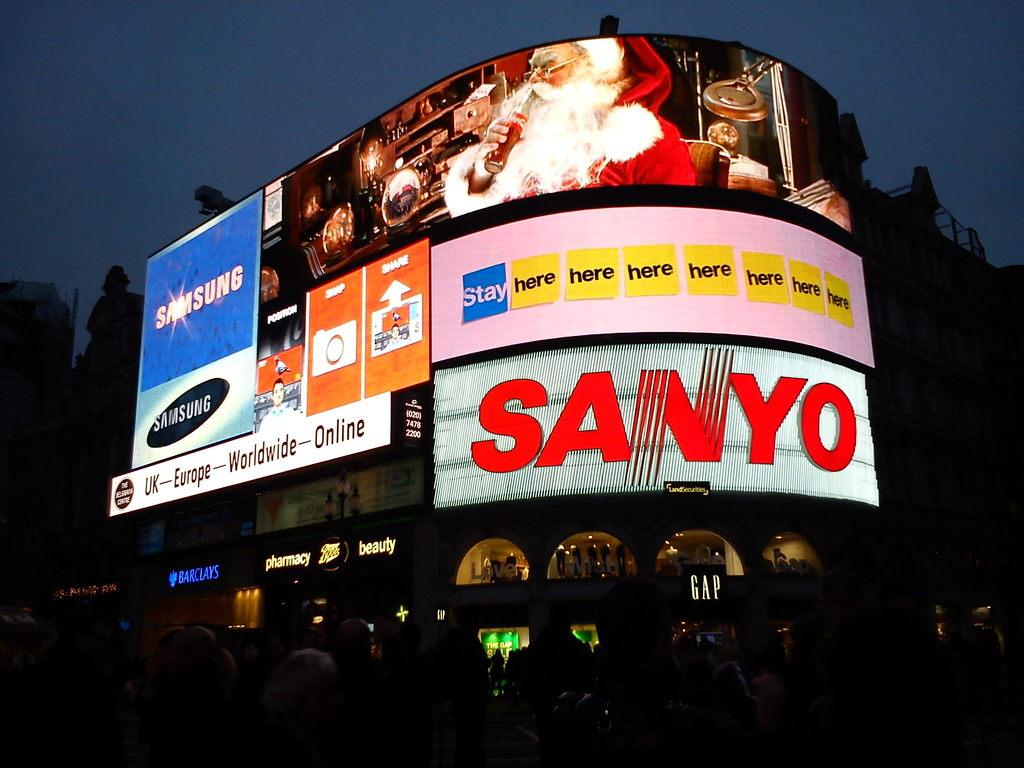<image>
Offer a succinct explanation of the picture presented. A Sanyo sign is lit up with a picture of Santa above. 